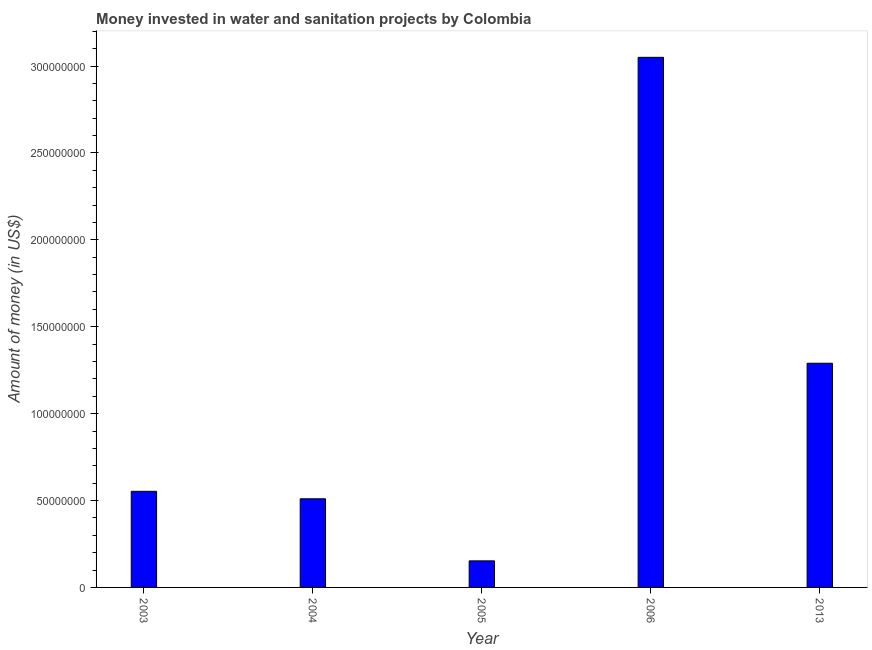Does the graph contain any zero values?
Provide a short and direct response. No. Does the graph contain grids?
Give a very brief answer. No. What is the title of the graph?
Offer a very short reply. Money invested in water and sanitation projects by Colombia. What is the label or title of the X-axis?
Keep it short and to the point. Year. What is the label or title of the Y-axis?
Your answer should be very brief. Amount of money (in US$). What is the investment in 2004?
Offer a terse response. 5.10e+07. Across all years, what is the maximum investment?
Offer a terse response. 3.05e+08. Across all years, what is the minimum investment?
Provide a succinct answer. 1.53e+07. In which year was the investment maximum?
Provide a succinct answer. 2006. What is the sum of the investment?
Ensure brevity in your answer.  5.56e+08. What is the difference between the investment in 2003 and 2013?
Make the answer very short. -7.37e+07. What is the average investment per year?
Offer a terse response. 1.11e+08. What is the median investment?
Offer a terse response. 5.53e+07. In how many years, is the investment greater than 110000000 US$?
Provide a succinct answer. 2. What is the ratio of the investment in 2004 to that in 2005?
Offer a terse response. 3.34. What is the difference between the highest and the second highest investment?
Give a very brief answer. 1.76e+08. Is the sum of the investment in 2006 and 2013 greater than the maximum investment across all years?
Your response must be concise. Yes. What is the difference between the highest and the lowest investment?
Provide a succinct answer. 2.90e+08. How many bars are there?
Make the answer very short. 5. Are all the bars in the graph horizontal?
Offer a very short reply. No. What is the difference between two consecutive major ticks on the Y-axis?
Offer a terse response. 5.00e+07. What is the Amount of money (in US$) of 2003?
Give a very brief answer. 5.53e+07. What is the Amount of money (in US$) of 2004?
Offer a terse response. 5.10e+07. What is the Amount of money (in US$) of 2005?
Provide a succinct answer. 1.53e+07. What is the Amount of money (in US$) in 2006?
Your response must be concise. 3.05e+08. What is the Amount of money (in US$) in 2013?
Offer a terse response. 1.29e+08. What is the difference between the Amount of money (in US$) in 2003 and 2004?
Your answer should be compact. 4.30e+06. What is the difference between the Amount of money (in US$) in 2003 and 2005?
Provide a short and direct response. 4.00e+07. What is the difference between the Amount of money (in US$) in 2003 and 2006?
Provide a succinct answer. -2.50e+08. What is the difference between the Amount of money (in US$) in 2003 and 2013?
Offer a very short reply. -7.37e+07. What is the difference between the Amount of money (in US$) in 2004 and 2005?
Your answer should be very brief. 3.57e+07. What is the difference between the Amount of money (in US$) in 2004 and 2006?
Ensure brevity in your answer.  -2.54e+08. What is the difference between the Amount of money (in US$) in 2004 and 2013?
Provide a short and direct response. -7.80e+07. What is the difference between the Amount of money (in US$) in 2005 and 2006?
Provide a succinct answer. -2.90e+08. What is the difference between the Amount of money (in US$) in 2005 and 2013?
Your answer should be compact. -1.14e+08. What is the difference between the Amount of money (in US$) in 2006 and 2013?
Offer a very short reply. 1.76e+08. What is the ratio of the Amount of money (in US$) in 2003 to that in 2004?
Your response must be concise. 1.08. What is the ratio of the Amount of money (in US$) in 2003 to that in 2005?
Your answer should be compact. 3.62. What is the ratio of the Amount of money (in US$) in 2003 to that in 2006?
Your response must be concise. 0.18. What is the ratio of the Amount of money (in US$) in 2003 to that in 2013?
Give a very brief answer. 0.43. What is the ratio of the Amount of money (in US$) in 2004 to that in 2005?
Make the answer very short. 3.34. What is the ratio of the Amount of money (in US$) in 2004 to that in 2006?
Your answer should be very brief. 0.17. What is the ratio of the Amount of money (in US$) in 2004 to that in 2013?
Offer a very short reply. 0.4. What is the ratio of the Amount of money (in US$) in 2005 to that in 2006?
Give a very brief answer. 0.05. What is the ratio of the Amount of money (in US$) in 2005 to that in 2013?
Your answer should be very brief. 0.12. What is the ratio of the Amount of money (in US$) in 2006 to that in 2013?
Ensure brevity in your answer.  2.36. 